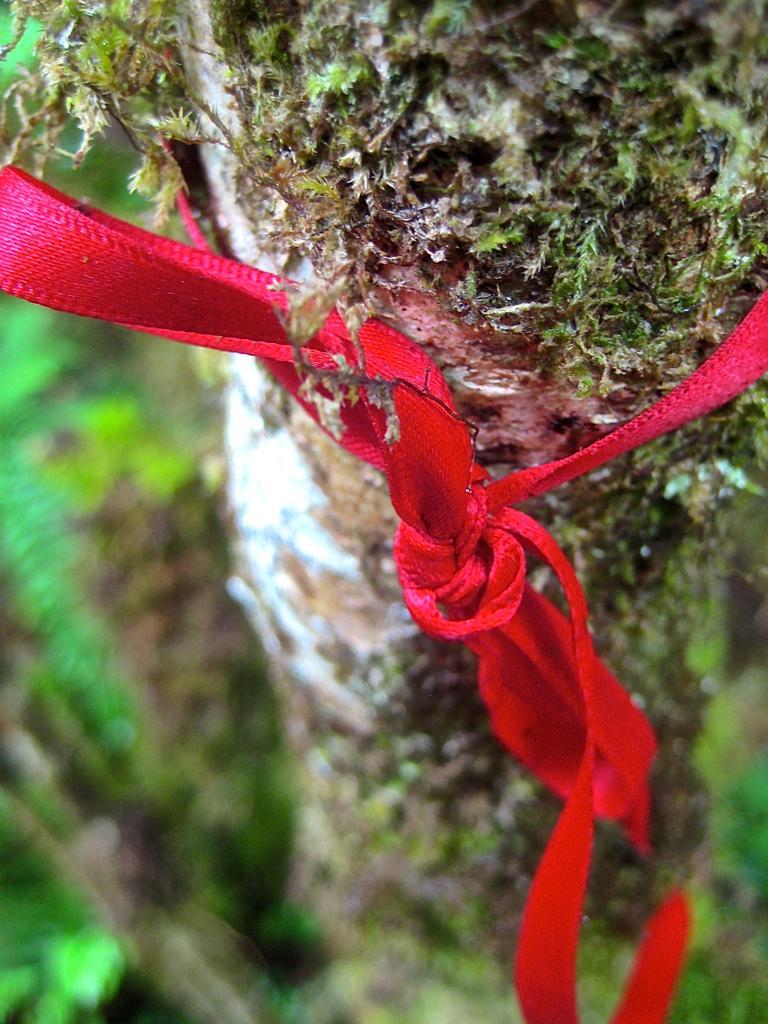Please provide a concise description of this image. In this image we can see bark of a tree and a rope tied to it. 